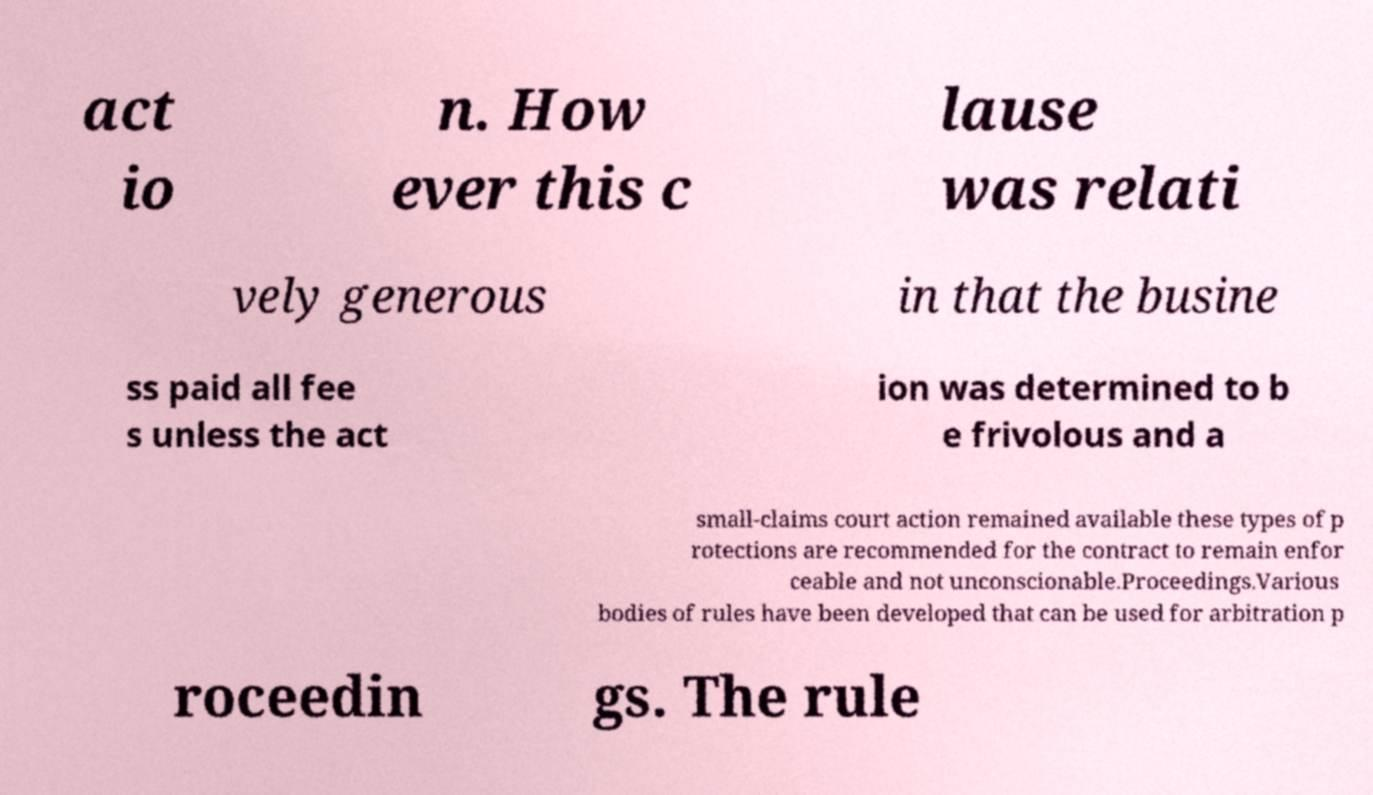For documentation purposes, I need the text within this image transcribed. Could you provide that? act io n. How ever this c lause was relati vely generous in that the busine ss paid all fee s unless the act ion was determined to b e frivolous and a small-claims court action remained available these types of p rotections are recommended for the contract to remain enfor ceable and not unconscionable.Proceedings.Various bodies of rules have been developed that can be used for arbitration p roceedin gs. The rule 